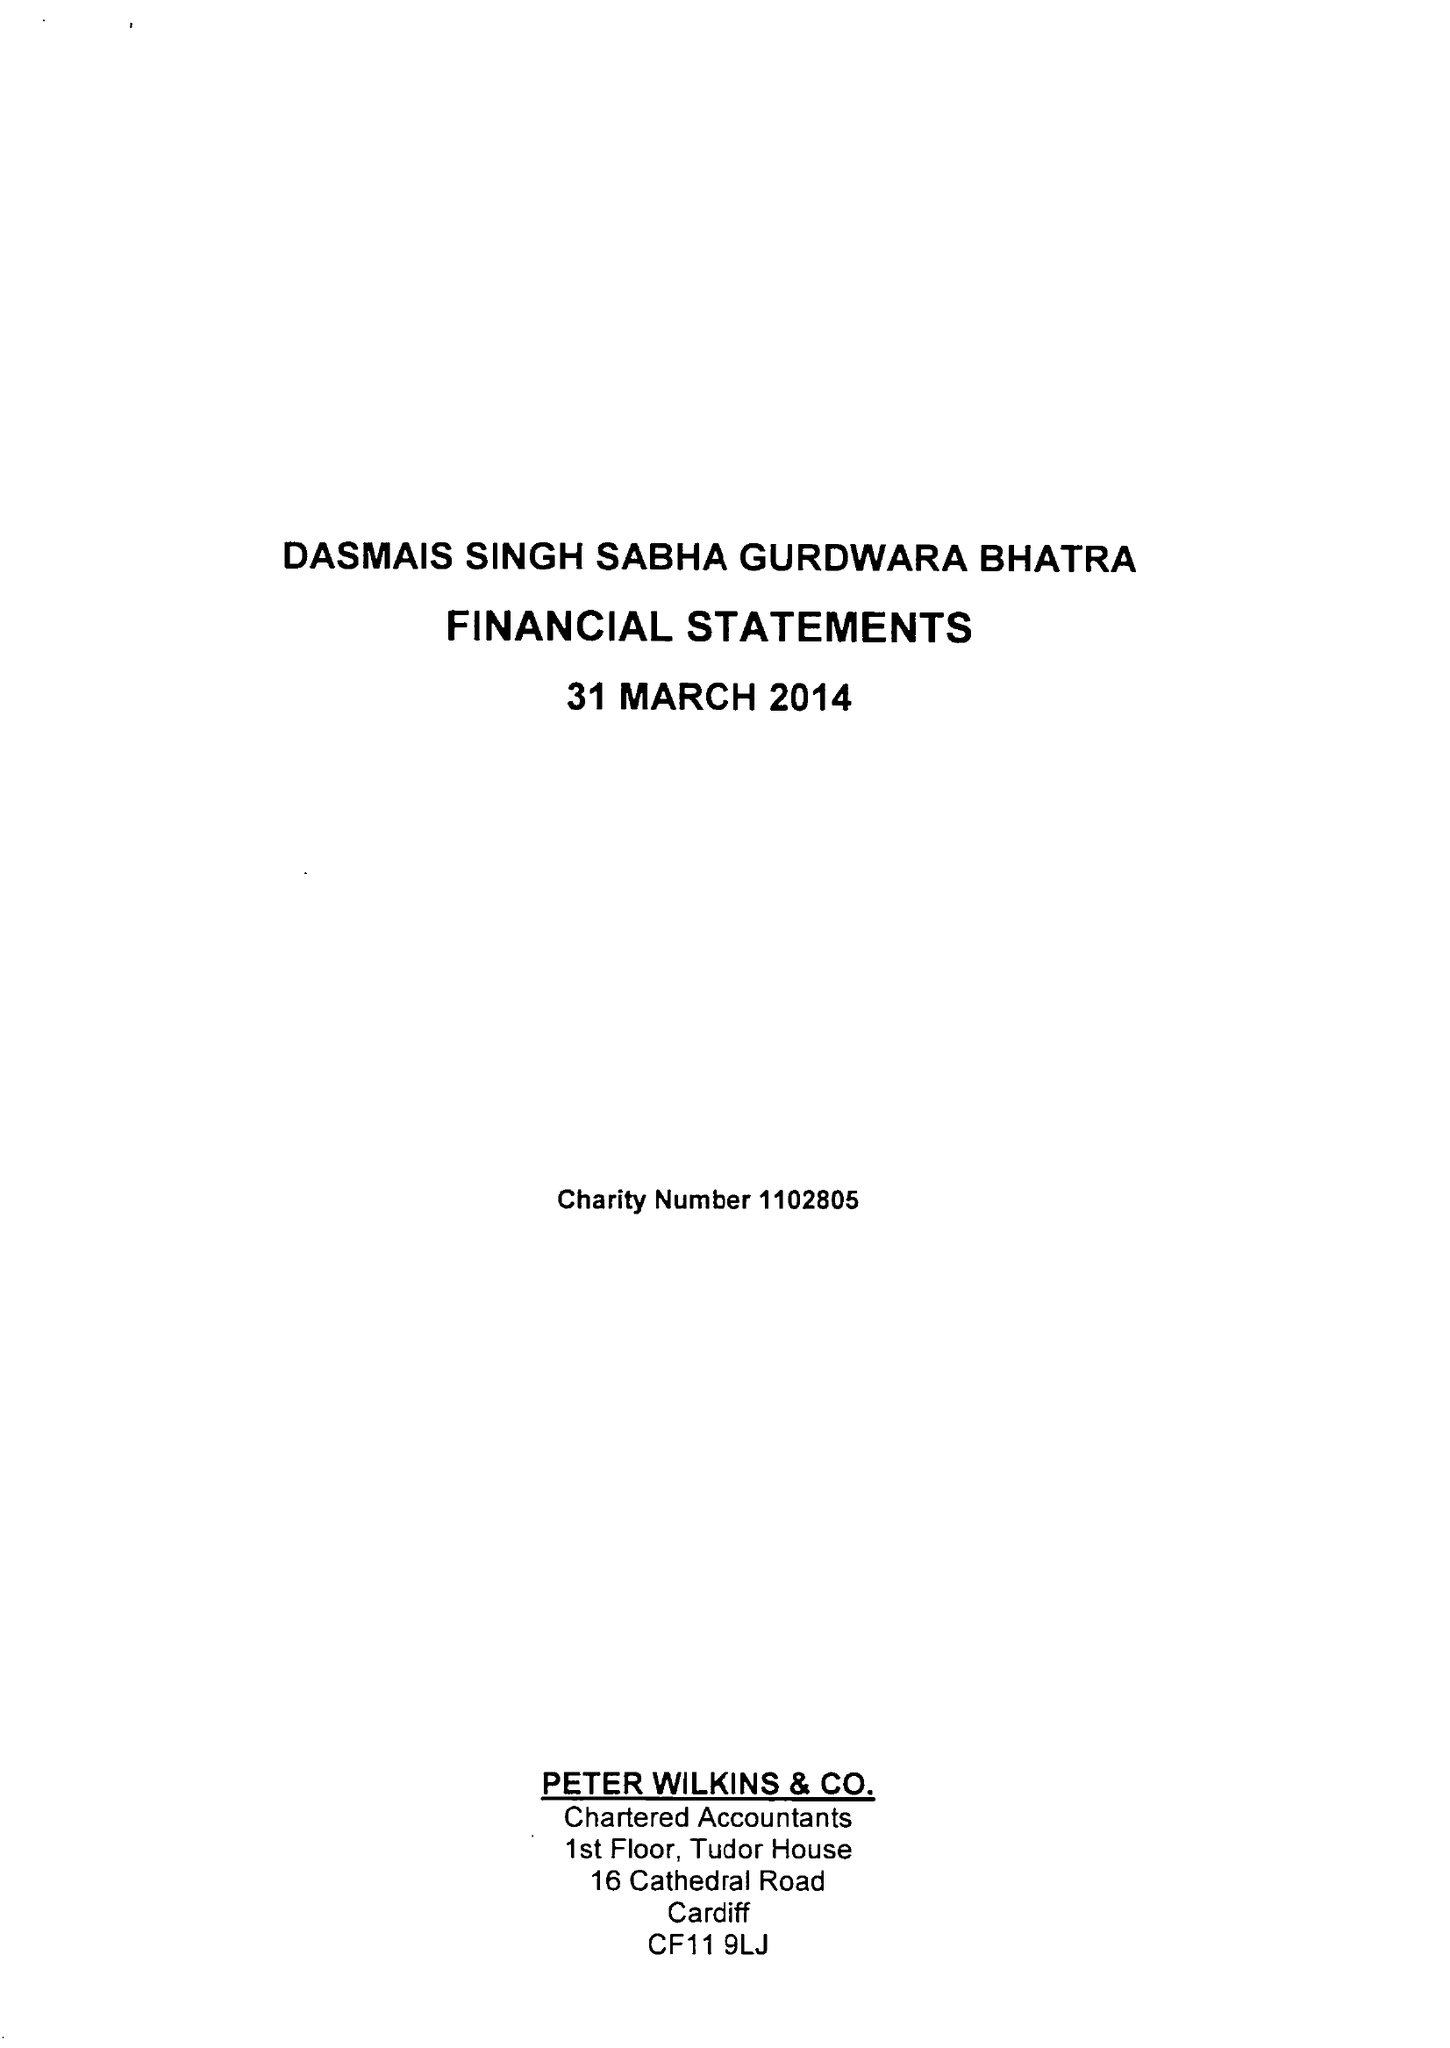What is the value for the spending_annually_in_british_pounds?
Answer the question using a single word or phrase. 33905.00 